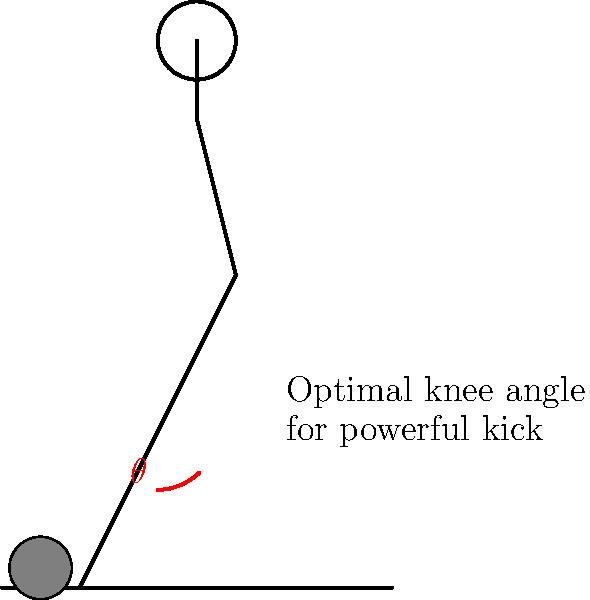As a Wolves supporter who's seen many powerful shots at Molineux, you know the importance of proper kicking technique. What is the optimal knee angle $\theta$ for a player to achieve maximum power when striking the ball, as illustrated in the diagram? To understand the optimal knee angle for a powerful kick, let's break it down step-by-step:

1. The power in a soccer kick comes from the transfer of energy from the leg to the ball.

2. This energy transfer is maximized when the leg can accelerate through a larger range of motion.

3. A fully extended leg (180°) or a fully bent leg (close to 0°) would limit this range of motion.

4. Research in sports biomechanics has shown that the optimal knee angle at the start of the kicking motion is approximately 110-120° from full extension.

5. This means the optimal angle $\theta$ in our diagram, which measures from the vertical, would be:

   $\theta = 180° - (110° \text{ to } 120°) = 60° \text{ to } 70°$

6. This angle allows for:
   a) Sufficient wind-up to generate power
   b) Enough extension to transfer energy efficiently to the ball
   c) Optimal muscle engagement of the quadriceps and hamstrings

7. It's worth noting that slight variations can occur based on individual player physiology and kick type.

8. Wolves players like Rúben Neves, known for powerful long-range shots, likely utilize this optimal knee angle in their kicking technique.
Answer: 60° to 70° 